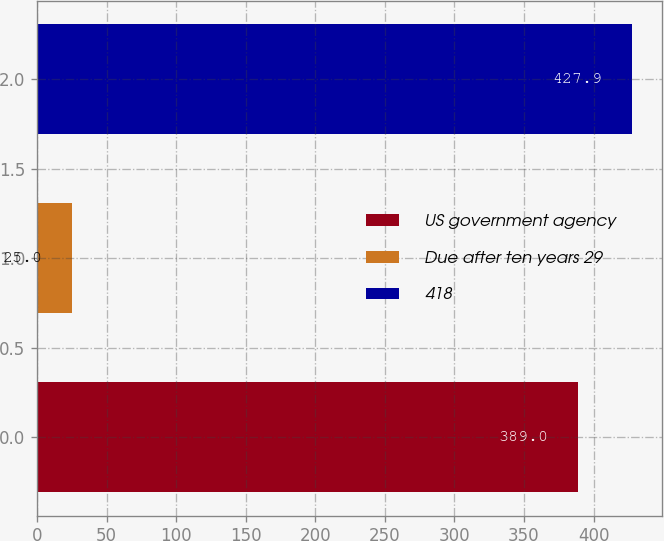Convert chart to OTSL. <chart><loc_0><loc_0><loc_500><loc_500><bar_chart><fcel>US government agency<fcel>Due after ten years 29<fcel>418<nl><fcel>389<fcel>25<fcel>427.9<nl></chart> 